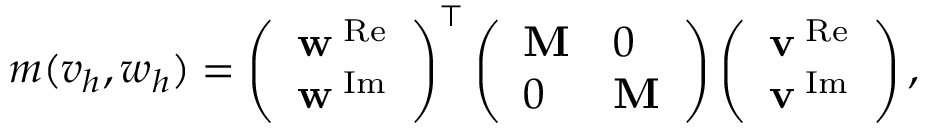<formula> <loc_0><loc_0><loc_500><loc_500>\begin{array} { r } { m ( v _ { h } , w _ { h } ) = \left ( \begin{array} { l } { w ^ { \mathrm { R e } } } \\ { w ^ { \mathrm { I m } } } \end{array} \right ) ^ { \top } \left ( \begin{array} { l l } { M } & { 0 } \\ { 0 } & { M } \end{array} \right ) \left ( \begin{array} { l } { v ^ { \mathrm { R e } } } \\ { v ^ { \mathrm { I m } } } \end{array} \right ) , } \end{array}</formula> 